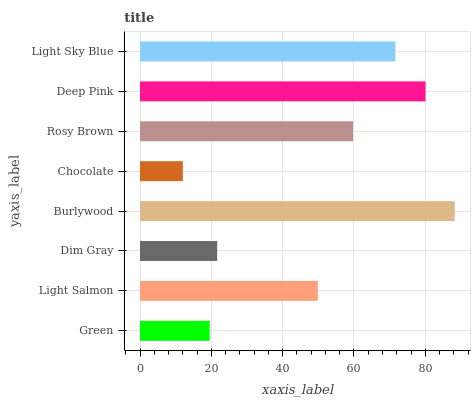Is Chocolate the minimum?
Answer yes or no. Yes. Is Burlywood the maximum?
Answer yes or no. Yes. Is Light Salmon the minimum?
Answer yes or no. No. Is Light Salmon the maximum?
Answer yes or no. No. Is Light Salmon greater than Green?
Answer yes or no. Yes. Is Green less than Light Salmon?
Answer yes or no. Yes. Is Green greater than Light Salmon?
Answer yes or no. No. Is Light Salmon less than Green?
Answer yes or no. No. Is Rosy Brown the high median?
Answer yes or no. Yes. Is Light Salmon the low median?
Answer yes or no. Yes. Is Green the high median?
Answer yes or no. No. Is Burlywood the low median?
Answer yes or no. No. 